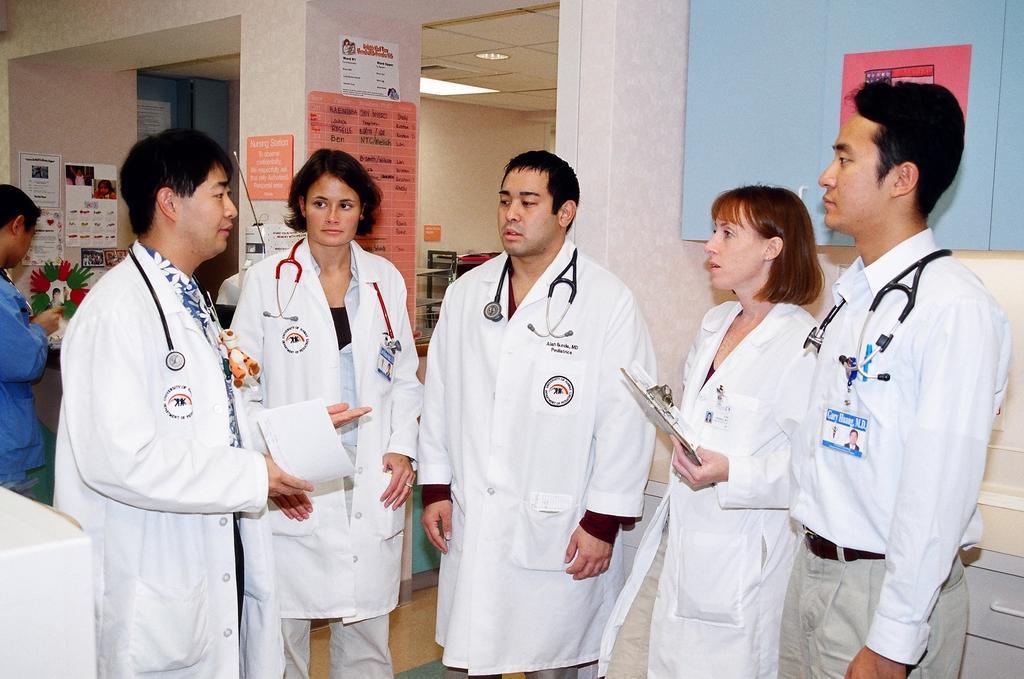Could you give a brief overview of what you see in this image? In the picture there are a group of doctors standing and discussing, behind them on the left side there is a nurse and in front of the nurse there are many posters attached to the walls and pillars. 